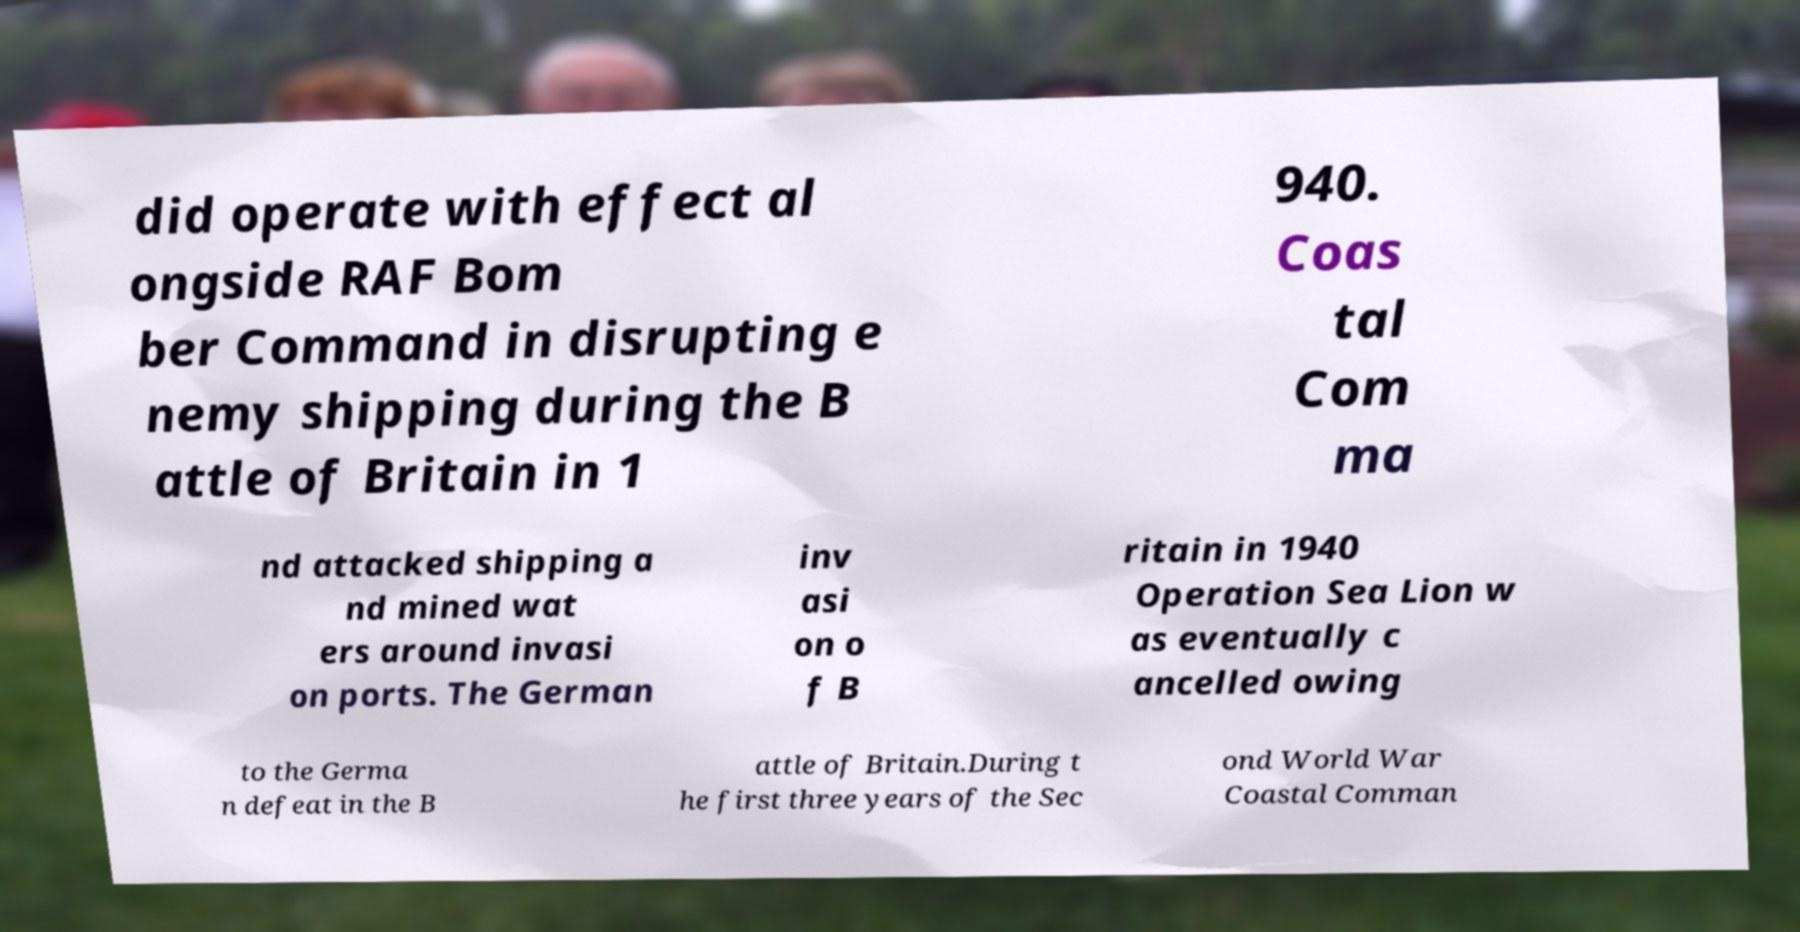For documentation purposes, I need the text within this image transcribed. Could you provide that? did operate with effect al ongside RAF Bom ber Command in disrupting e nemy shipping during the B attle of Britain in 1 940. Coas tal Com ma nd attacked shipping a nd mined wat ers around invasi on ports. The German inv asi on o f B ritain in 1940 Operation Sea Lion w as eventually c ancelled owing to the Germa n defeat in the B attle of Britain.During t he first three years of the Sec ond World War Coastal Comman 